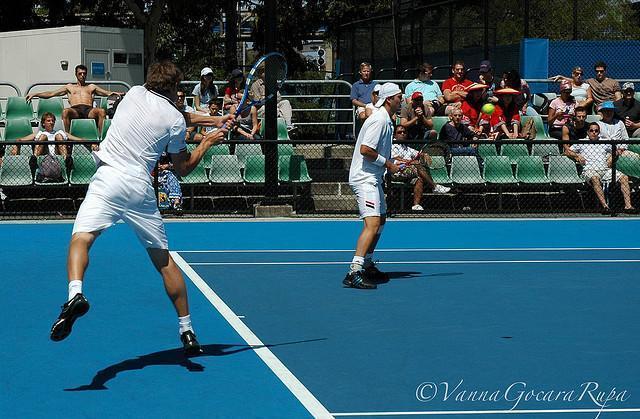How many players are wearing hats?
Give a very brief answer. 1. How many yellow balls on the ground?
Give a very brief answer. 0. How many people are there?
Give a very brief answer. 3. 